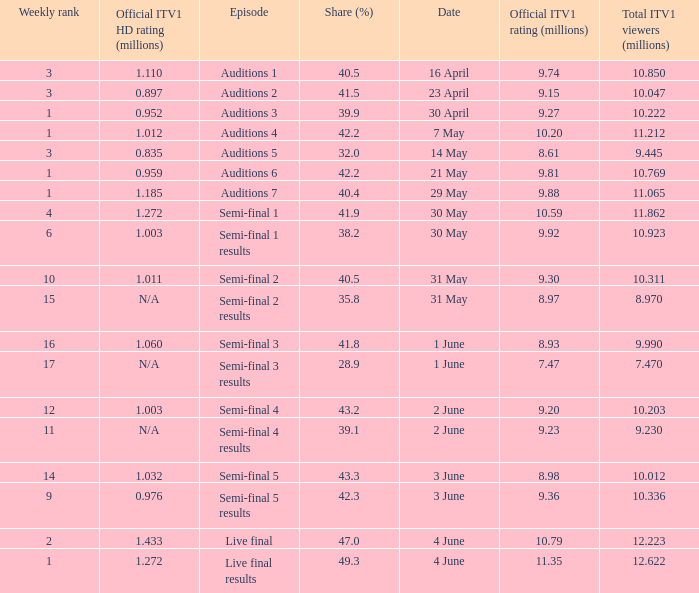What was the total ITV1 viewers in millions for the episode with a share (%) of 28.9?  7.47. 